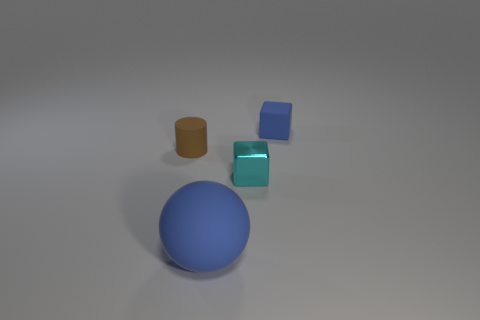How many spheres are either small green rubber things or tiny cyan shiny objects? In the image, there is one large blue sphere, one small orange cylinder, one small brown cube, and one tiny cyan shiny cube. Therefore, based on the properties you asked for, there are zero small green rubber spheres or tiny cyan shiny spheres. However, there is one tiny cyan shiny cube that partially fits the criteria mentioned. 